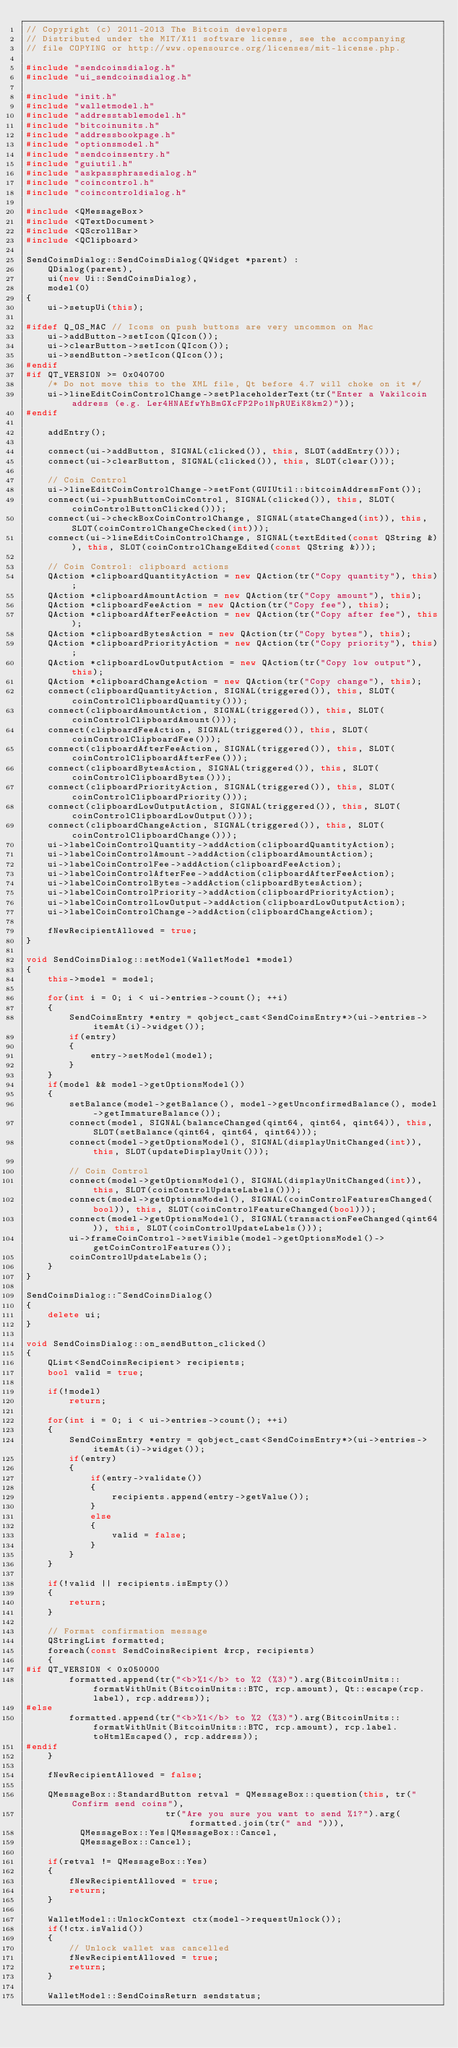<code> <loc_0><loc_0><loc_500><loc_500><_C++_>// Copyright (c) 2011-2013 The Bitcoin developers
// Distributed under the MIT/X11 software license, see the accompanying
// file COPYING or http://www.opensource.org/licenses/mit-license.php.

#include "sendcoinsdialog.h"
#include "ui_sendcoinsdialog.h"

#include "init.h"
#include "walletmodel.h"
#include "addresstablemodel.h"
#include "bitcoinunits.h"
#include "addressbookpage.h"
#include "optionsmodel.h"
#include "sendcoinsentry.h"
#include "guiutil.h"
#include "askpassphrasedialog.h"
#include "coincontrol.h"
#include "coincontroldialog.h"

#include <QMessageBox>
#include <QTextDocument>
#include <QScrollBar>
#include <QClipboard>

SendCoinsDialog::SendCoinsDialog(QWidget *parent) :
    QDialog(parent),
    ui(new Ui::SendCoinsDialog),
    model(0)
{
    ui->setupUi(this);

#ifdef Q_OS_MAC // Icons on push buttons are very uncommon on Mac
    ui->addButton->setIcon(QIcon());
    ui->clearButton->setIcon(QIcon());
    ui->sendButton->setIcon(QIcon());
#endif
#if QT_VERSION >= 0x040700
    /* Do not move this to the XML file, Qt before 4.7 will choke on it */
    ui->lineEditCoinControlChange->setPlaceholderText(tr("Enter a Vakilcoin address (e.g. Ler4HNAEfwYhBmGXcFP2Po1NpRUEiK8km2)"));
#endif

    addEntry();

    connect(ui->addButton, SIGNAL(clicked()), this, SLOT(addEntry()));
    connect(ui->clearButton, SIGNAL(clicked()), this, SLOT(clear()));

    // Coin Control
    ui->lineEditCoinControlChange->setFont(GUIUtil::bitcoinAddressFont());
    connect(ui->pushButtonCoinControl, SIGNAL(clicked()), this, SLOT(coinControlButtonClicked()));
    connect(ui->checkBoxCoinControlChange, SIGNAL(stateChanged(int)), this, SLOT(coinControlChangeChecked(int)));
    connect(ui->lineEditCoinControlChange, SIGNAL(textEdited(const QString &)), this, SLOT(coinControlChangeEdited(const QString &)));

    // Coin Control: clipboard actions
    QAction *clipboardQuantityAction = new QAction(tr("Copy quantity"), this);
    QAction *clipboardAmountAction = new QAction(tr("Copy amount"), this);
    QAction *clipboardFeeAction = new QAction(tr("Copy fee"), this);
    QAction *clipboardAfterFeeAction = new QAction(tr("Copy after fee"), this);
    QAction *clipboardBytesAction = new QAction(tr("Copy bytes"), this);
    QAction *clipboardPriorityAction = new QAction(tr("Copy priority"), this);
    QAction *clipboardLowOutputAction = new QAction(tr("Copy low output"), this);
    QAction *clipboardChangeAction = new QAction(tr("Copy change"), this);
    connect(clipboardQuantityAction, SIGNAL(triggered()), this, SLOT(coinControlClipboardQuantity()));
    connect(clipboardAmountAction, SIGNAL(triggered()), this, SLOT(coinControlClipboardAmount()));
    connect(clipboardFeeAction, SIGNAL(triggered()), this, SLOT(coinControlClipboardFee()));
    connect(clipboardAfterFeeAction, SIGNAL(triggered()), this, SLOT(coinControlClipboardAfterFee()));
    connect(clipboardBytesAction, SIGNAL(triggered()), this, SLOT(coinControlClipboardBytes()));
    connect(clipboardPriorityAction, SIGNAL(triggered()), this, SLOT(coinControlClipboardPriority()));
    connect(clipboardLowOutputAction, SIGNAL(triggered()), this, SLOT(coinControlClipboardLowOutput()));
    connect(clipboardChangeAction, SIGNAL(triggered()), this, SLOT(coinControlClipboardChange()));
    ui->labelCoinControlQuantity->addAction(clipboardQuantityAction);
    ui->labelCoinControlAmount->addAction(clipboardAmountAction);
    ui->labelCoinControlFee->addAction(clipboardFeeAction);
    ui->labelCoinControlAfterFee->addAction(clipboardAfterFeeAction);
    ui->labelCoinControlBytes->addAction(clipboardBytesAction);
    ui->labelCoinControlPriority->addAction(clipboardPriorityAction);
    ui->labelCoinControlLowOutput->addAction(clipboardLowOutputAction);
    ui->labelCoinControlChange->addAction(clipboardChangeAction);

    fNewRecipientAllowed = true;
}

void SendCoinsDialog::setModel(WalletModel *model)
{
    this->model = model;

    for(int i = 0; i < ui->entries->count(); ++i)
    {
        SendCoinsEntry *entry = qobject_cast<SendCoinsEntry*>(ui->entries->itemAt(i)->widget());
        if(entry)
        {
            entry->setModel(model);
        }
    }
    if(model && model->getOptionsModel())
    {
        setBalance(model->getBalance(), model->getUnconfirmedBalance(), model->getImmatureBalance());
        connect(model, SIGNAL(balanceChanged(qint64, qint64, qint64)), this, SLOT(setBalance(qint64, qint64, qint64)));
        connect(model->getOptionsModel(), SIGNAL(displayUnitChanged(int)), this, SLOT(updateDisplayUnit()));

        // Coin Control
        connect(model->getOptionsModel(), SIGNAL(displayUnitChanged(int)), this, SLOT(coinControlUpdateLabels()));
        connect(model->getOptionsModel(), SIGNAL(coinControlFeaturesChanged(bool)), this, SLOT(coinControlFeatureChanged(bool)));
        connect(model->getOptionsModel(), SIGNAL(transactionFeeChanged(qint64)), this, SLOT(coinControlUpdateLabels()));
        ui->frameCoinControl->setVisible(model->getOptionsModel()->getCoinControlFeatures());
        coinControlUpdateLabels();
    }
}

SendCoinsDialog::~SendCoinsDialog()
{
    delete ui;
}

void SendCoinsDialog::on_sendButton_clicked()
{
    QList<SendCoinsRecipient> recipients;
    bool valid = true;

    if(!model)
        return;

    for(int i = 0; i < ui->entries->count(); ++i)
    {
        SendCoinsEntry *entry = qobject_cast<SendCoinsEntry*>(ui->entries->itemAt(i)->widget());
        if(entry)
        {
            if(entry->validate())
            {
                recipients.append(entry->getValue());
            }
            else
            {
                valid = false;
            }
        }
    }

    if(!valid || recipients.isEmpty())
    {
        return;
    }

    // Format confirmation message
    QStringList formatted;
    foreach(const SendCoinsRecipient &rcp, recipients)
    {
#if QT_VERSION < 0x050000
        formatted.append(tr("<b>%1</b> to %2 (%3)").arg(BitcoinUnits::formatWithUnit(BitcoinUnits::BTC, rcp.amount), Qt::escape(rcp.label), rcp.address));
#else
        formatted.append(tr("<b>%1</b> to %2 (%3)").arg(BitcoinUnits::formatWithUnit(BitcoinUnits::BTC, rcp.amount), rcp.label.toHtmlEscaped(), rcp.address));
#endif
    }

    fNewRecipientAllowed = false;

    QMessageBox::StandardButton retval = QMessageBox::question(this, tr("Confirm send coins"),
                          tr("Are you sure you want to send %1?").arg(formatted.join(tr(" and "))),
          QMessageBox::Yes|QMessageBox::Cancel,
          QMessageBox::Cancel);

    if(retval != QMessageBox::Yes)
    {
        fNewRecipientAllowed = true;
        return;
    }

    WalletModel::UnlockContext ctx(model->requestUnlock());
    if(!ctx.isValid())
    {
        // Unlock wallet was cancelled
        fNewRecipientAllowed = true;
        return;
    }

    WalletModel::SendCoinsReturn sendstatus;</code> 